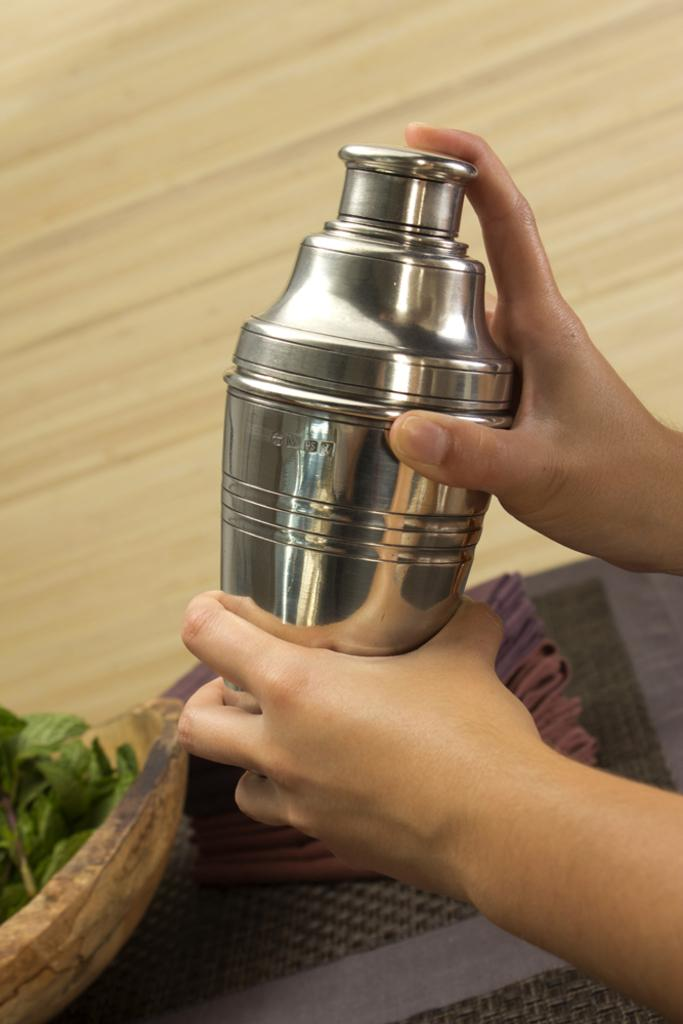Who is present in the image? There is a man in the image. What is the man holding in the image? The man is holding a metal bottle. What object can be seen on the wooden plate? Mint leaves are on the wooden plate. What type of surface is visible in the background of the image? There is a table in the background of the image. What type of cough medicine is on the table in the image? There is no cough medicine present in the image; it features a man holding a metal bottle and mint leaves on a wooden plate. What type of scale is visible on the table in the image? There is no scale present in the image; it only features a man, a metal bottle, a wooden plate with mint leaves, and a table in the background. 